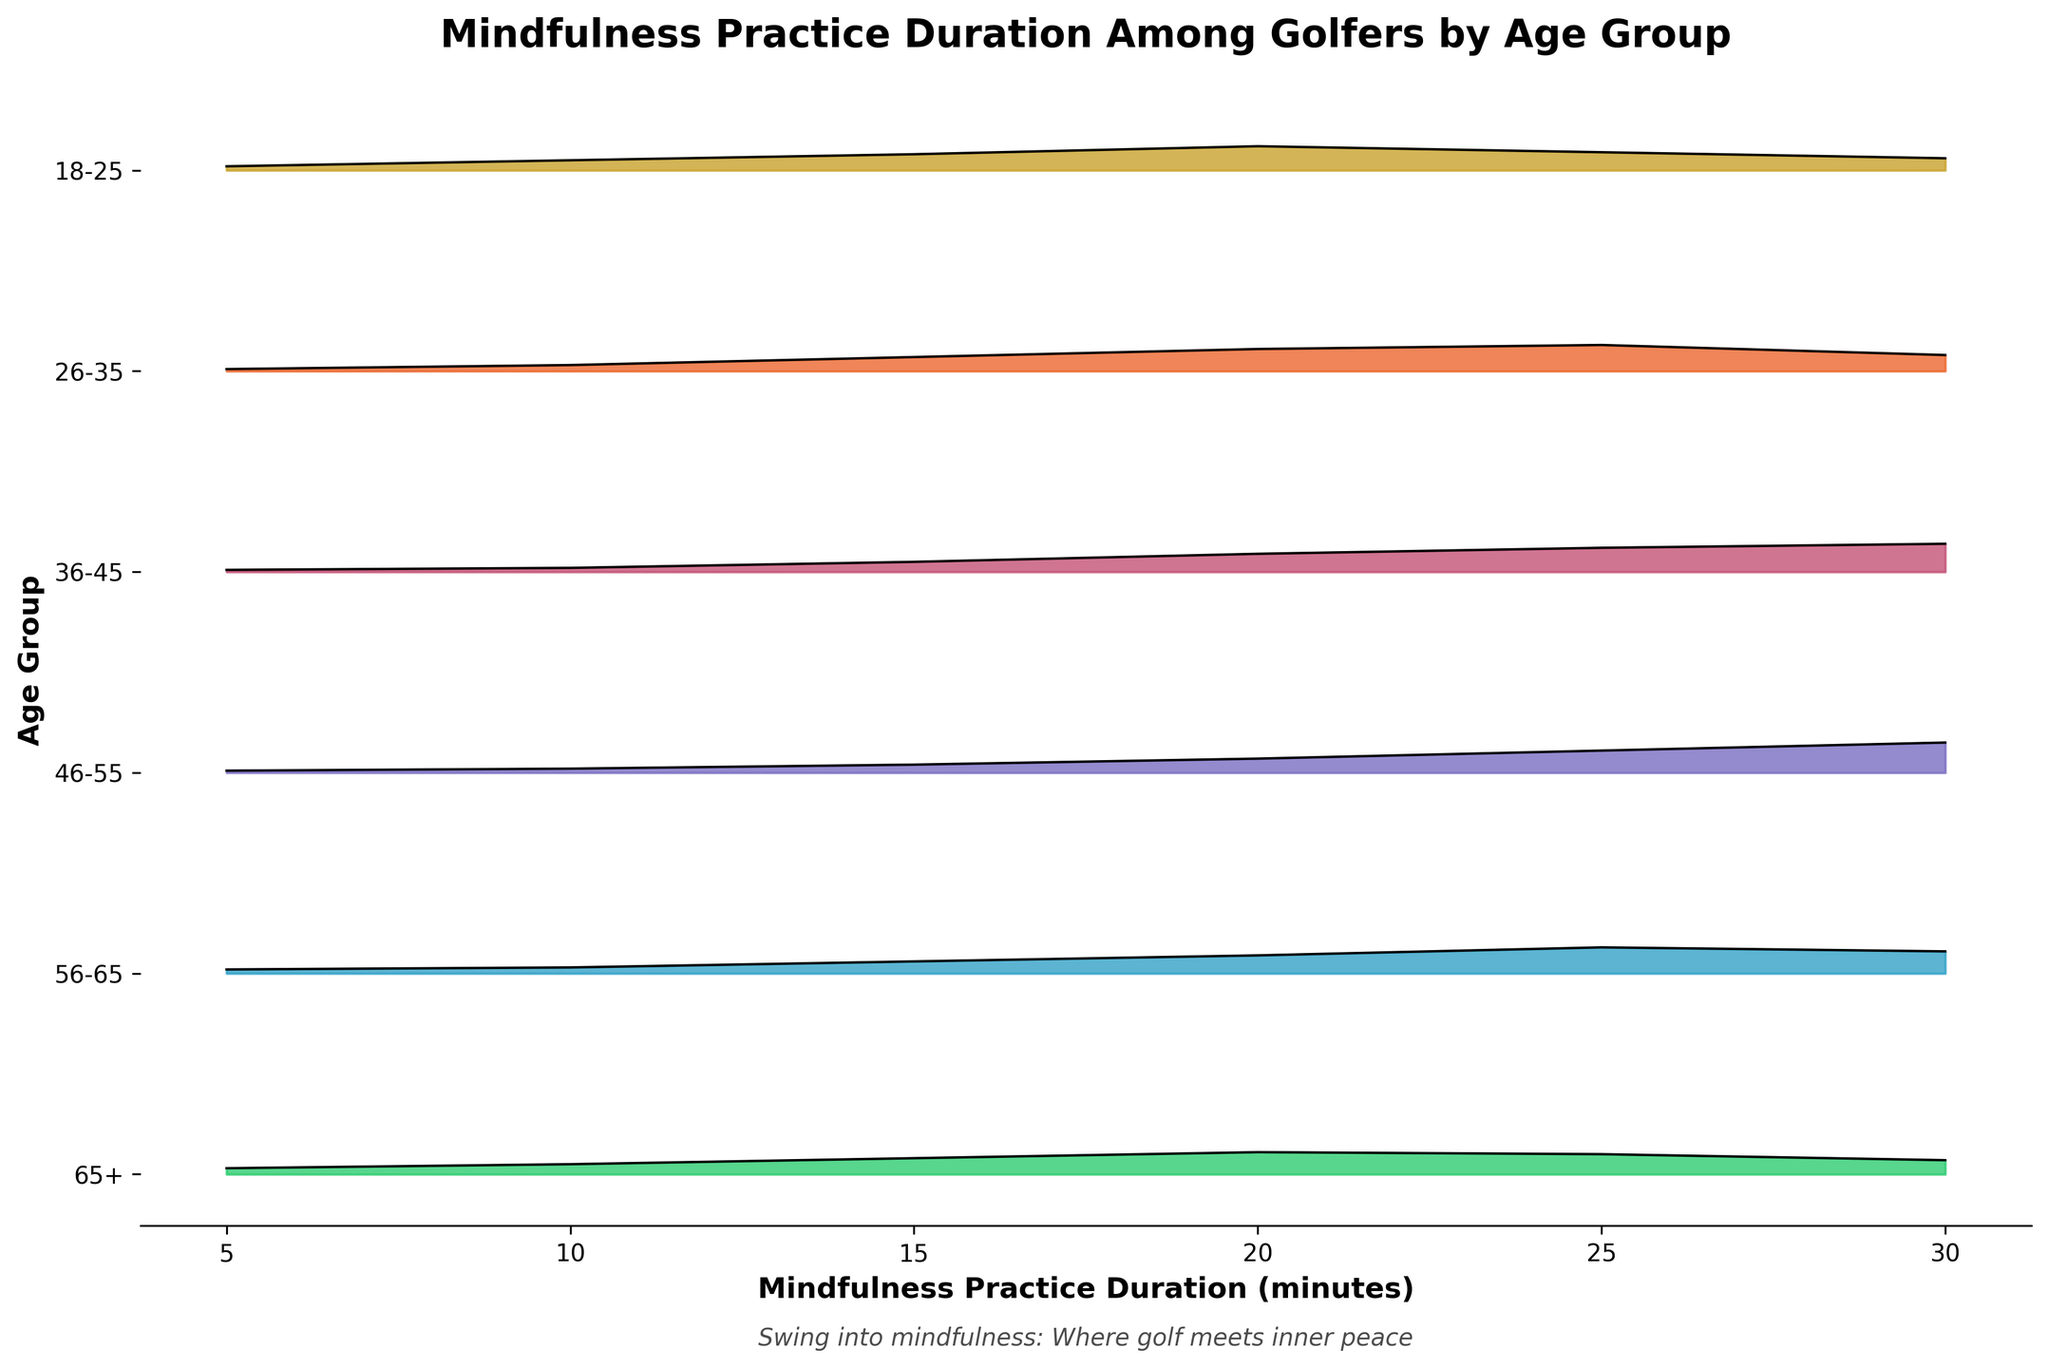What is the title of the figure? The title is located at the top of the figure. It should be the most prominent text and describes what the figure is about.
Answer: "Mindfulness Practice Duration Among Golfers by Age Group" What does the x-axis represent? The x-axis label typically describes what the horizontal line denotes in the figure. In this case, it should clarify what is being measured along the x-axis.
Answer: Mindfulness Practice Duration (minutes) Which age group has the highest density at 30 minutes? To answer this, examine the highest peak for the 30-minute mark across all age groups. Find the age group that corresponds to the highest value.
Answer: 46-55 Which age group shows the closest density values at 20 minutes and at 25 minutes? Look at the density values for 20 minutes and 25 minutes in each age group and identify the group where these values are closest to each other.
Answer: 65+ How does the density of mindfulness duration distribution at 25 minutes compare between age groups 36-45 and 56-65? We need to compare the density values of the two specified age groups (36-45 and 56-65) at the 25-minute mark. Check the height of the curves at this duration.
Answer: 56-65 has a higher density than 36-45 Which age group shows the widest spread of mindfulness practice durations? The widest spread can be determined by finding the age group with the most extended range of durations where the density remains above zero. Observe where the peaks start and end for each group.
Answer: 18-25 For which age group is the peak density of mindfulness practice duration? Examine all age groups and identify the age group with the highest peak density value, indicating the most common duration of mindfulness practice.
Answer: 46-55 At which mindfulness duration do age groups 26-35 and 65+ have the same density? Check the density curves for the two age groups specified. Identify where the density values are equal for both, focusing on the x-axis (duration).
Answer: 10 minutes What's the general trend in the peak of mindfulness practice duration across increasing age groups? To determine the trend, observe the relative positions and heights of the peaks as age groups progress. Typically, the trend is upward, downward, or stable.
Answer: Peaks generally shift to higher durations and higher densities with age Which age group shows least variability in mindfulness practice duration? Variability can be assessed by observing the spread of their density curve—narrower spreads mean less variability. Find the age group with the tightest range.
Answer: 46-55 